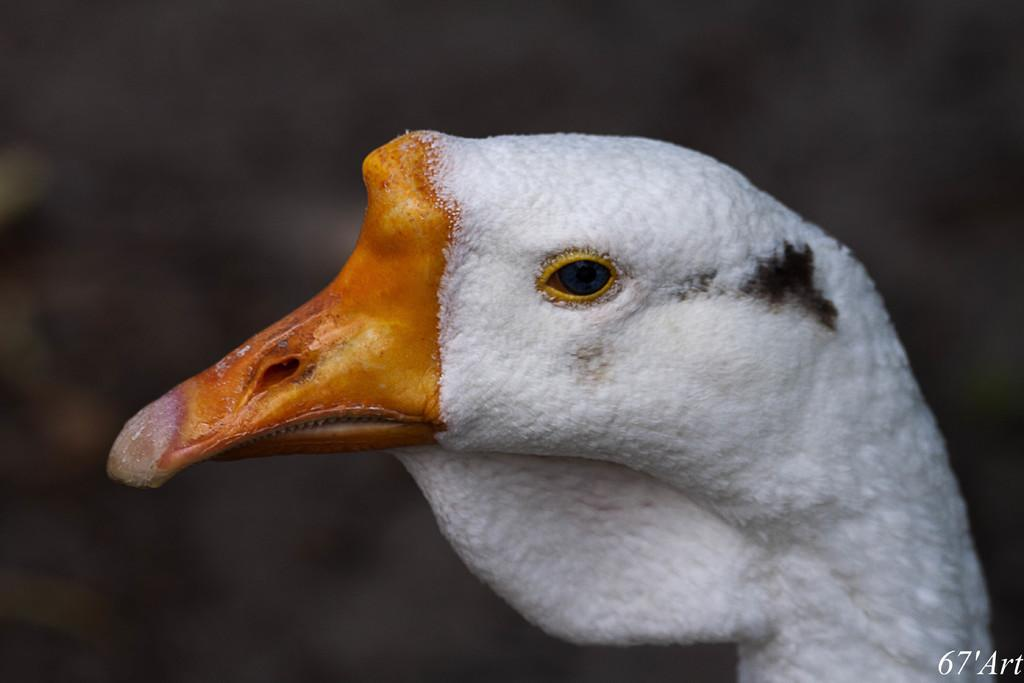What is the main subject of the image? The main subject of the image is a bird face. Is there any text present in the image? Yes, there is text at the bottom right corner of the image. What type of pipe can be seen in the image? There is no pipe present in the image; it features a bird face and text. What language is the text written in? The language of the text cannot be determined from the image alone, as it is not legible. 